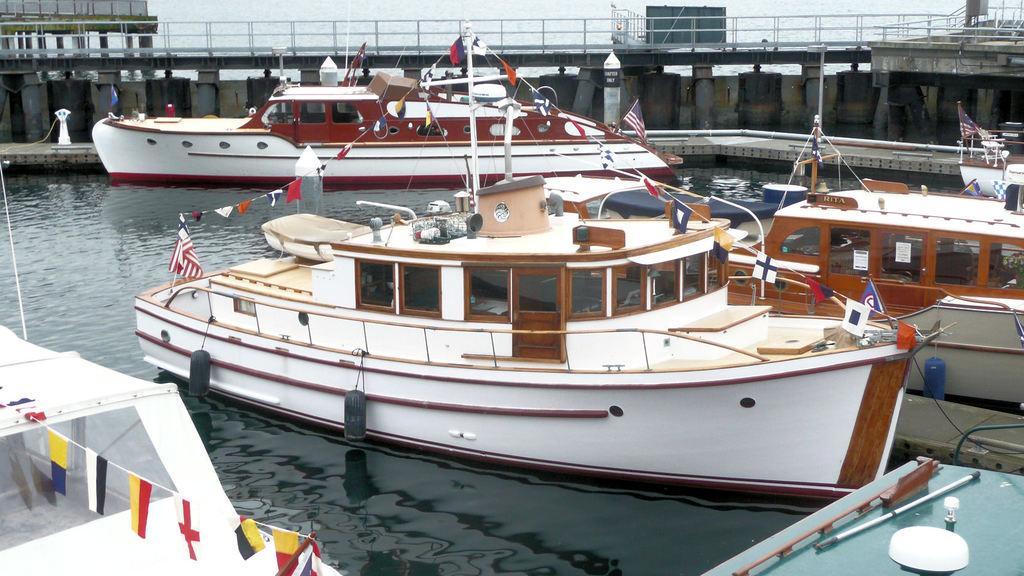Please provide a concise description of this image. In this image we can see boats in the water, here are the flags, there is the bridge, here are the pillars. 